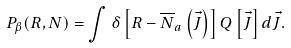<formula> <loc_0><loc_0><loc_500><loc_500>P _ { \beta } ( R , N ) = \int \delta \left [ R - { \overline { N } _ { a } } \left ( \vec { J } \right ) \right ] Q \left [ \vec { J } \right ] d { \vec { J } } .</formula> 